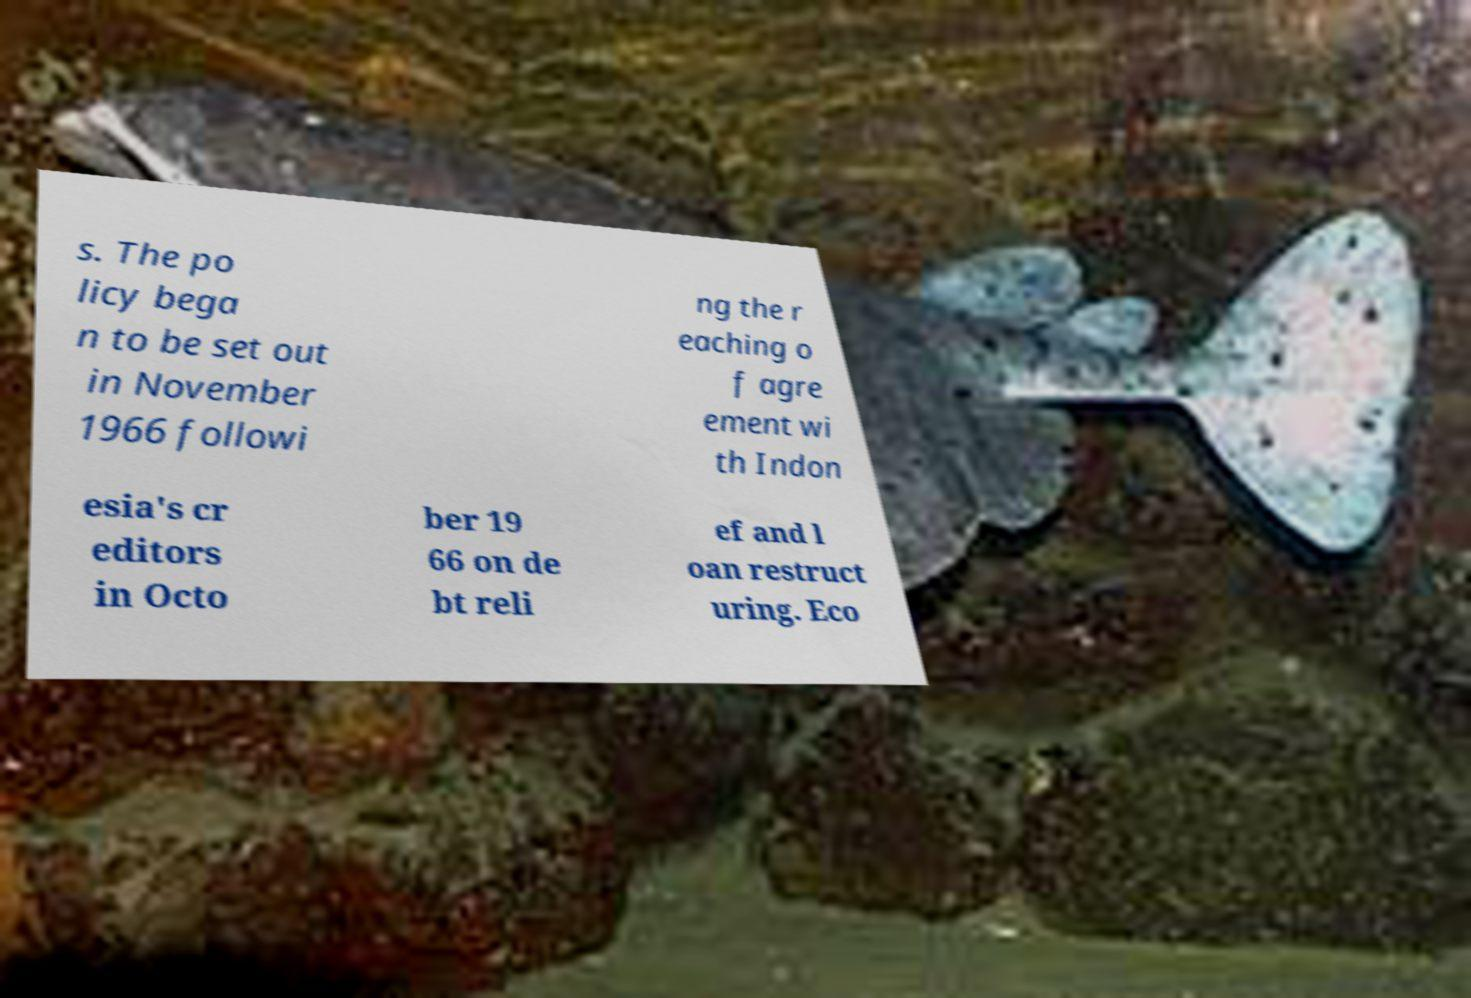Please identify and transcribe the text found in this image. s. The po licy bega n to be set out in November 1966 followi ng the r eaching o f agre ement wi th Indon esia's cr editors in Octo ber 19 66 on de bt reli ef and l oan restruct uring. Eco 